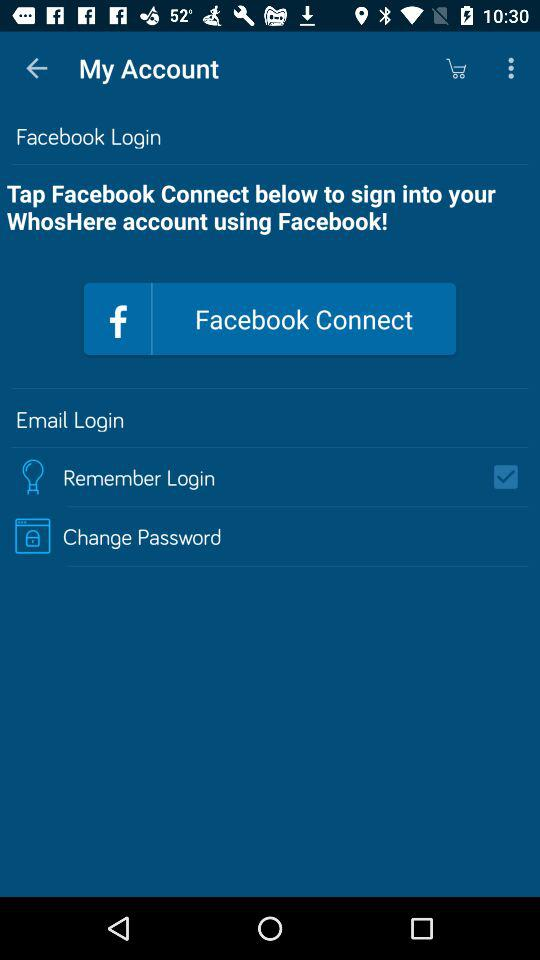Which accounts can I use to sign in? You can sign in with "Facebook". 